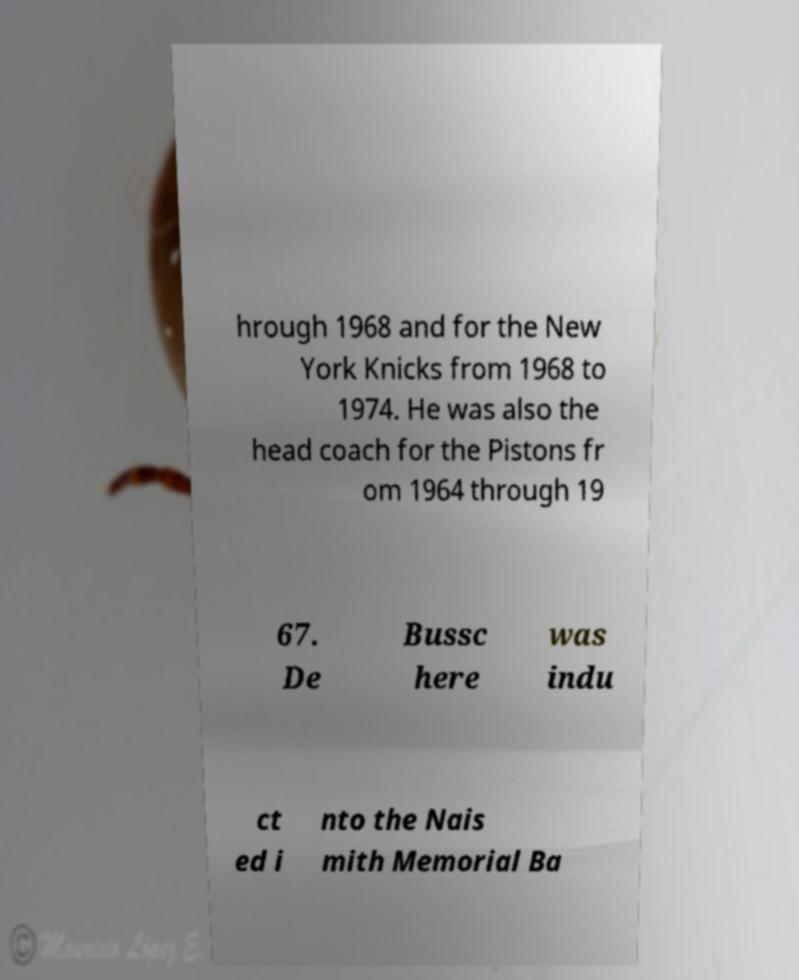Could you extract and type out the text from this image? hrough 1968 and for the New York Knicks from 1968 to 1974. He was also the head coach for the Pistons fr om 1964 through 19 67. De Bussc here was indu ct ed i nto the Nais mith Memorial Ba 